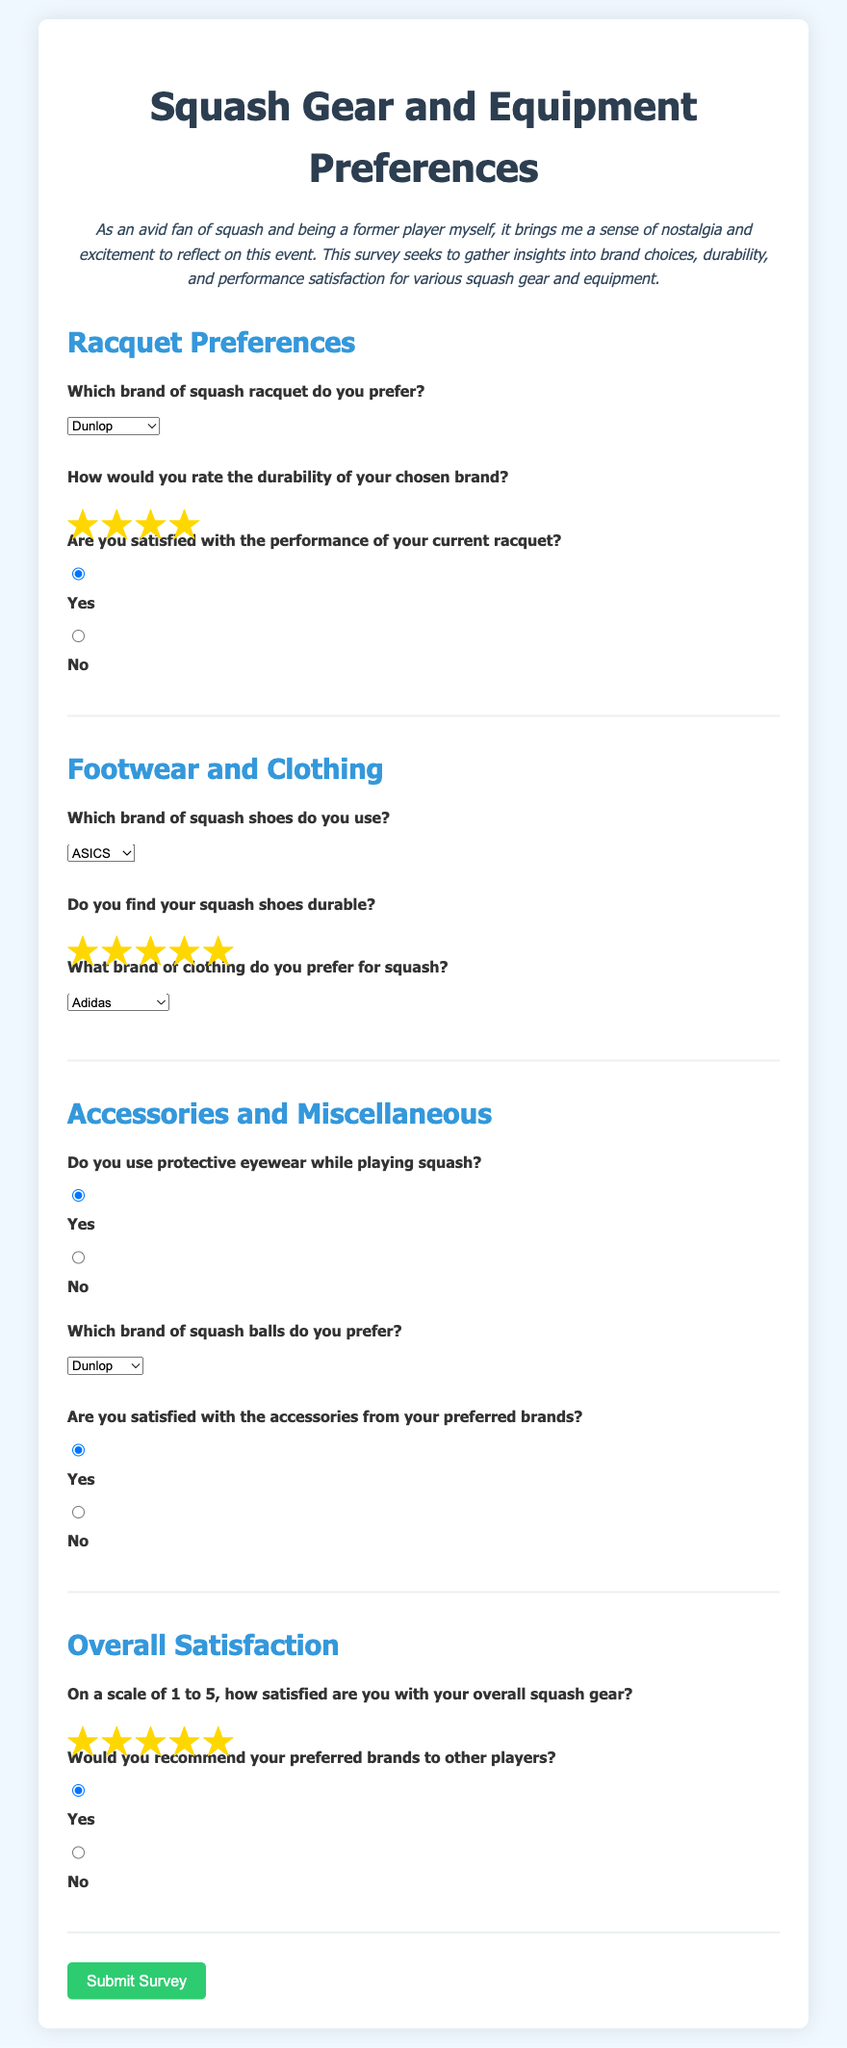What brand of squash racquet do you prefer? The user selected the brand of squash racquet in the dropdown menu, which is Dunlop.
Answer: Dunlop How would you rate the durability of your chosen brand? The user selected a rating to indicate durability from 1 to 5, and the chosen rating is 4.
Answer: 4 Are you satisfied with the performance of your current racquet? The user selected a yes or no option for satisfaction with racquet performance, and they indicated yes.
Answer: Yes Which brand of squash shoes do you use? The user selected the brand of squash shoes in the dropdown menu, which is ASICS.
Answer: ASICS Do you find your squash shoes durable? The user selected a rating for shoe durability from 1 to 5, and the chosen rating is 5.
Answer: 5 What brand of clothing do you prefer for squash? The user selected the brand of clothing from the dropdown menu, which is Adidas.
Answer: Adidas Do you use protective eyewear while playing squash? The user indicated their usage of protective eyewear by selecting yes or no, and they selected yes.
Answer: Yes Which brand of squash balls do you prefer? The user selected the brand of squash balls in the dropdown menu, which is Dunlop.
Answer: Dunlop On a scale of 1 to 5, how satisfied are you with your overall squash gear? The user selected a rating to indicate overall satisfaction from 1 to 5, with their chosen rating being 5.
Answer: 5 Would you recommend your preferred brands to other players? The user indicated their willingness to recommend preferred brands by selecting yes or no, and they selected yes.
Answer: Yes 